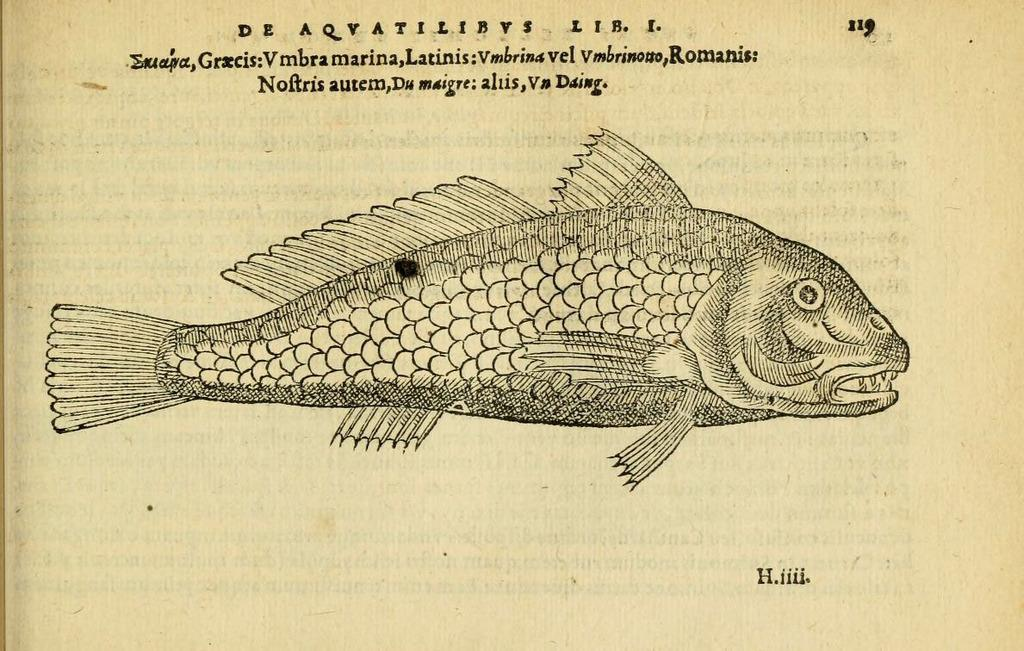What is depicted in the diagram in the image? There is a diagram of a fish in the image. What else can be seen on the paper besides the diagram? There are words on the paper. How can the specific page be identified? There is a page number on the paper. What type of twig is used as a prop in the image? There is no twig present in the image. What kind of art is displayed on the paper? The image only shows a diagram of a fish and words on the paper, not any form of art. 